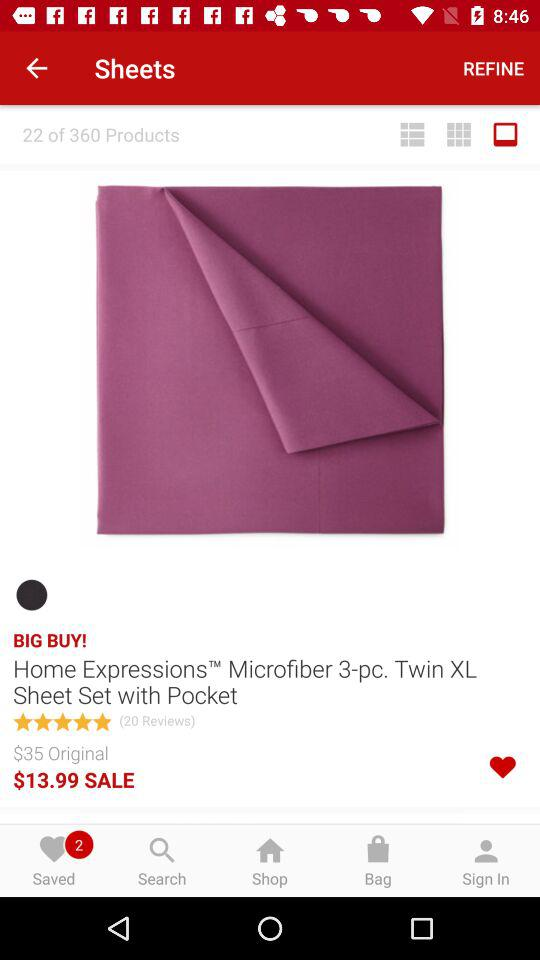What item is rated 5 stars? The item that is rated 5 stars is "Home Expressions Microfiber 3-pc. Twin XL Sheet Set with Pocket". 